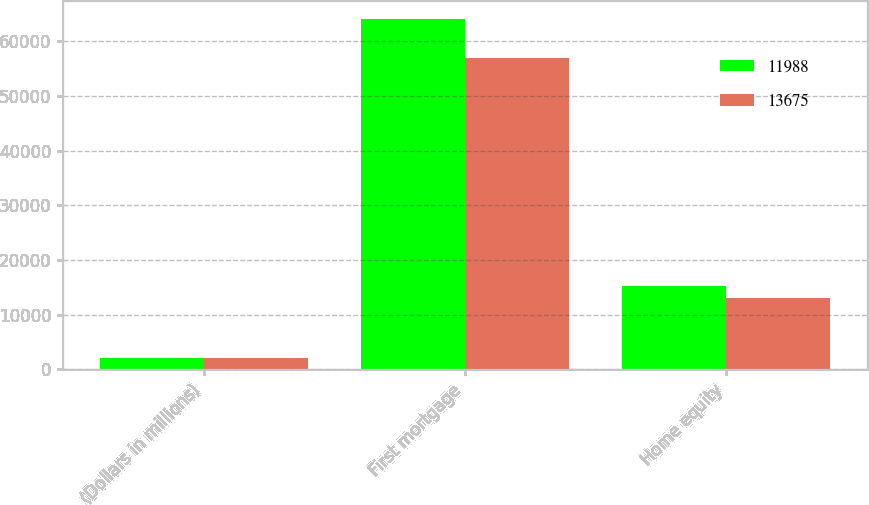Convert chart. <chart><loc_0><loc_0><loc_500><loc_500><stacked_bar_chart><ecel><fcel>(Dollars in millions)<fcel>First mortgage<fcel>Home equity<nl><fcel>11988<fcel>2016<fcel>64153<fcel>15214<nl><fcel>13675<fcel>2015<fcel>56930<fcel>13060<nl></chart> 